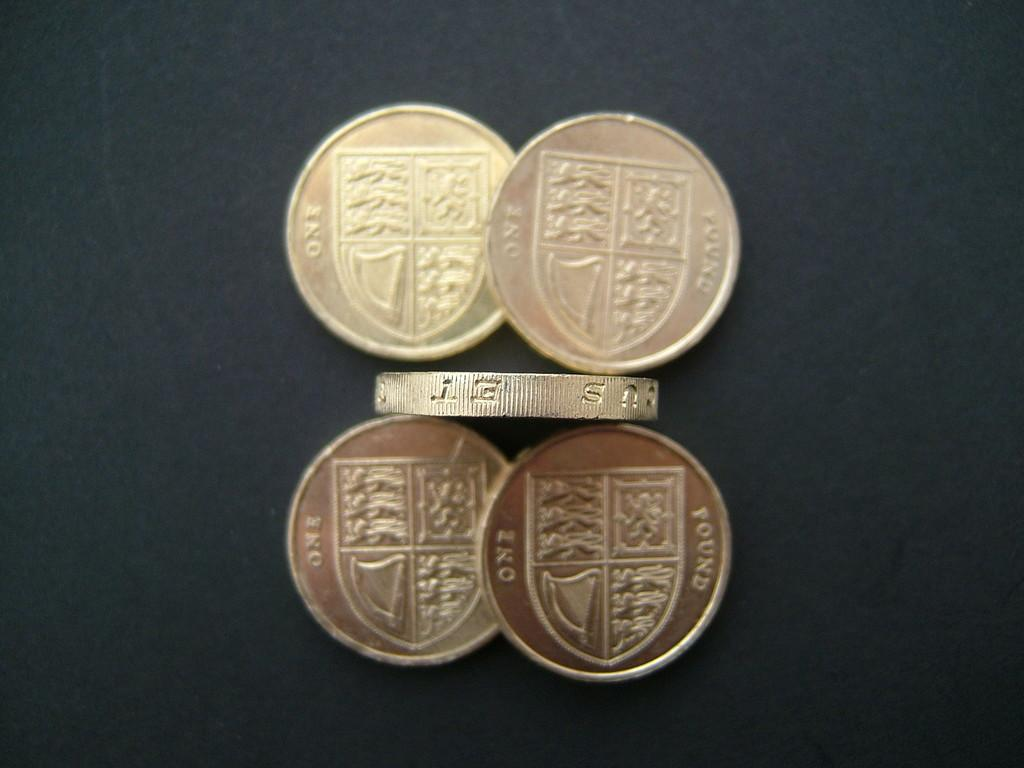<image>
Offer a succinct explanation of the picture presented. several coins for ONE POUND are grouped together 